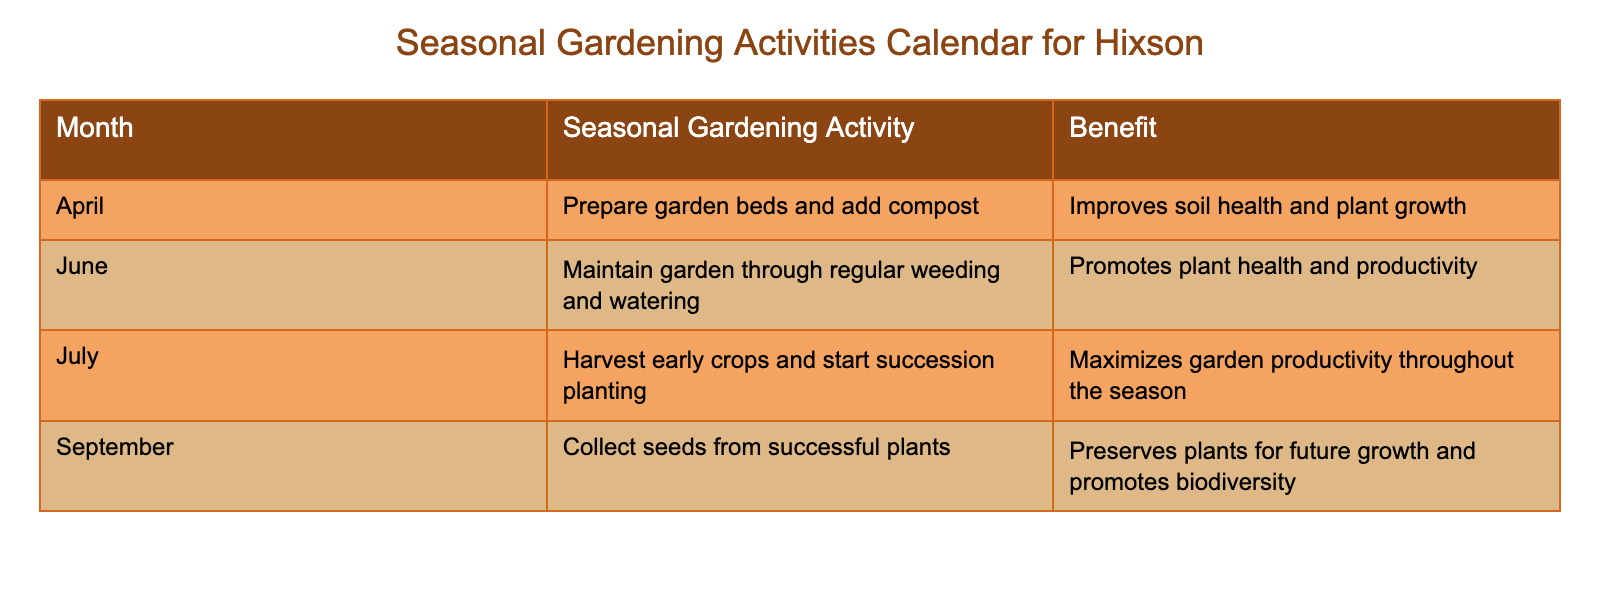What seasonal gardening activity is recommended for April? The table lists "Prepare garden beds and add compost" as the activity for April. By referring to the "Month" column and finding April, we can read across to the "Seasonal Gardening Activity" column for the corresponding activity.
Answer: Prepare garden beds and add compost What benefit is associated with harvesting early crops in July? According to the table, the benefit associated with harvesting early crops in July is to "Maximize garden productivity throughout the season." This is found in the corresponding row under the "Benefit" column.
Answer: Maximize garden productivity throughout the season In which month should gardeners collect seeds? The table indicates that seeds should be collected in September. By checking the "Month" column, we find that September corresponds with the activity of collecting seeds.
Answer: September What is the difference in the benefits of maintaining a garden in June versus collecting seeds in September? The benefit of maintaining the garden in June is "Promotes plant health and productivity," while the benefit of collecting seeds in September is "Preserves plants for future growth and promotes biodiversity." The difference between these two benefits highlights that maintenance in June focuses on immediate productivity, whereas September's activity is more about sustainability and preservation.
Answer: Immediate productivity versus sustainability Is it true that preparing garden beds improves soil health? Yes, the table states that preparing garden beds and adding compost in April "Improves soil health and plant growth." This is a clear benefit listed in the "Benefit" column for that activity.
Answer: Yes What are the seasonal gardening activities for June and July combined? In June, the activity is "Maintain garden through regular weeding and watering," and in July, it is "Harvest early crops and start succession planting." By combining these, we see that both months focus on maintenance and productivity. This means that gardeners should engage in both activities within that period to enhance their garden's health and output.
Answer: Maintenance and productivity activities How many seasonal activities are listed for the months from April to September? The table shows four distinct activities: one for April, one for June, one for July, and one for September. Counting these, we have a total of four seasonal gardening activities across the mentioned months.
Answer: Four Which month has an activity focused on preserving future plant growth? The month that emphasizes preserving future growth is September, where the activity listed is "Collect seeds from successful plants." This activity aims to ensure that gardeners can cultivate those successful plants again in the future.
Answer: September Overall, how do the benefits of June's and July's activities compare? The activities for June (maintaining the garden) and July (harvesting and succession planting) both focus on improving yield and productivity but from slightly different angles. June's benefit emphasizes ongoing care, while July's highlights maximizing output and future planning. This comparison shows how continuous care results in tangible benefits across the growing season.
Answer: Both focus on plant productivity but have different angles 